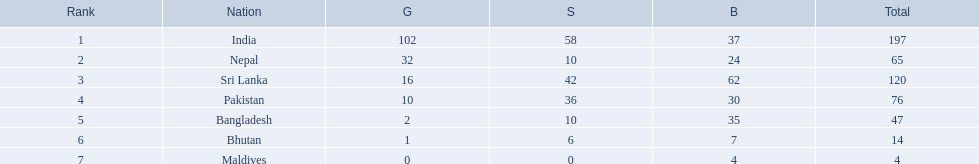What were the total amount won of medals by nations in the 1999 south asian games? 197, 65, 120, 76, 47, 14, 4. Which amount was the lowest? 4. Which nation had this amount? Maldives. 